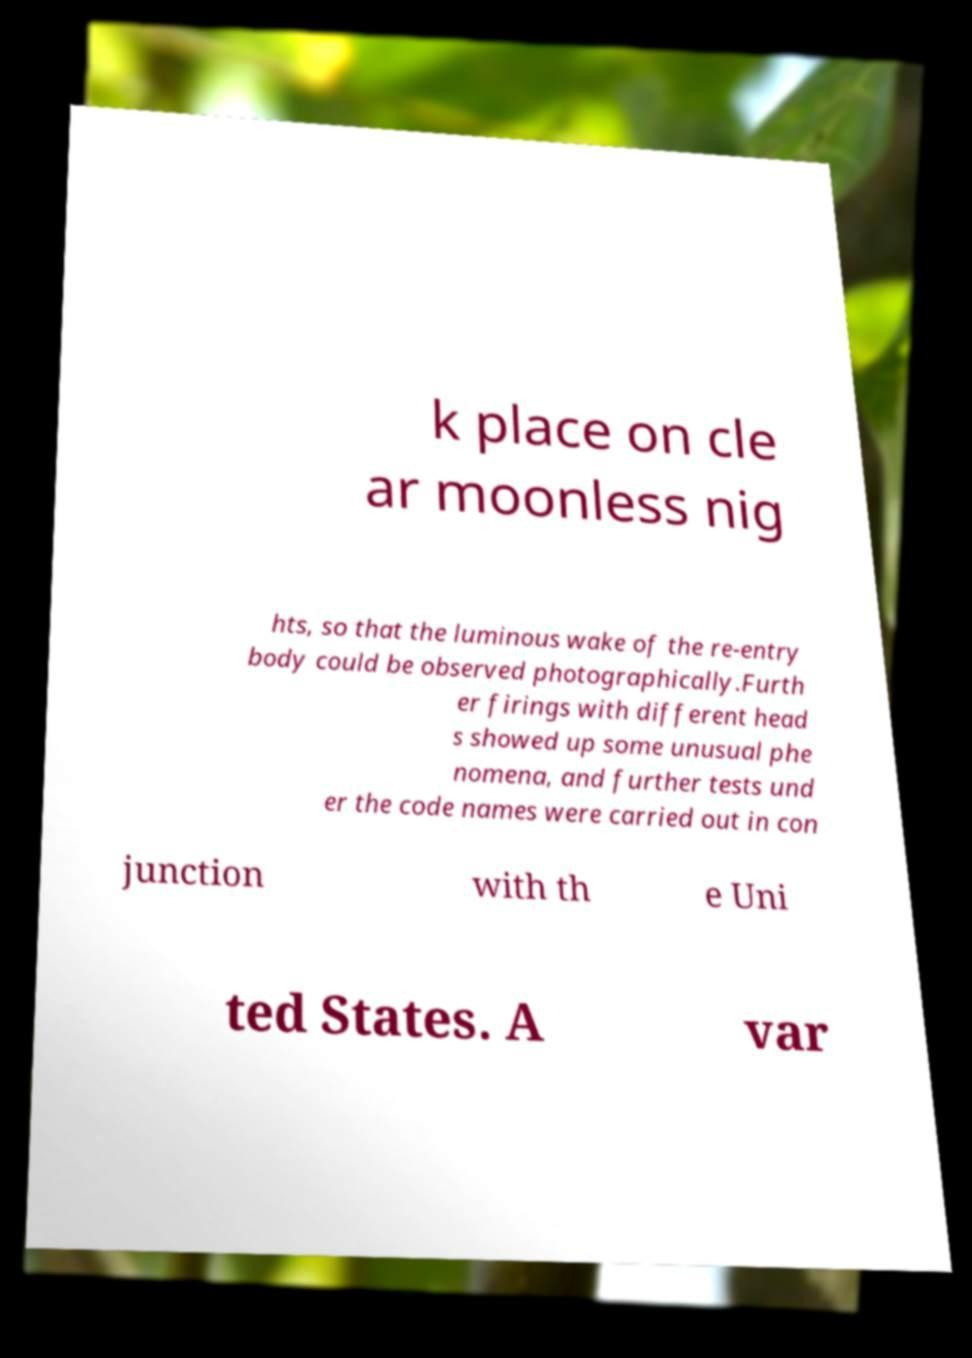Could you assist in decoding the text presented in this image and type it out clearly? k place on cle ar moonless nig hts, so that the luminous wake of the re-entry body could be observed photographically.Furth er firings with different head s showed up some unusual phe nomena, and further tests und er the code names were carried out in con junction with th e Uni ted States. A var 